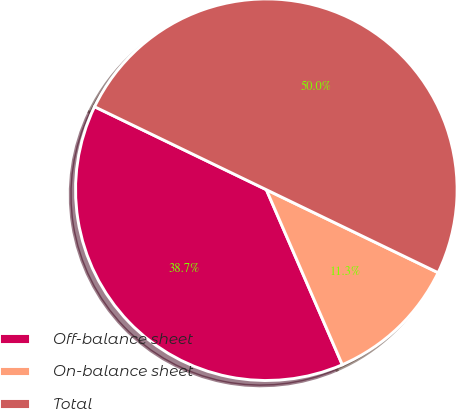<chart> <loc_0><loc_0><loc_500><loc_500><pie_chart><fcel>Off-balance sheet<fcel>On-balance sheet<fcel>Total<nl><fcel>38.68%<fcel>11.32%<fcel>50.0%<nl></chart> 